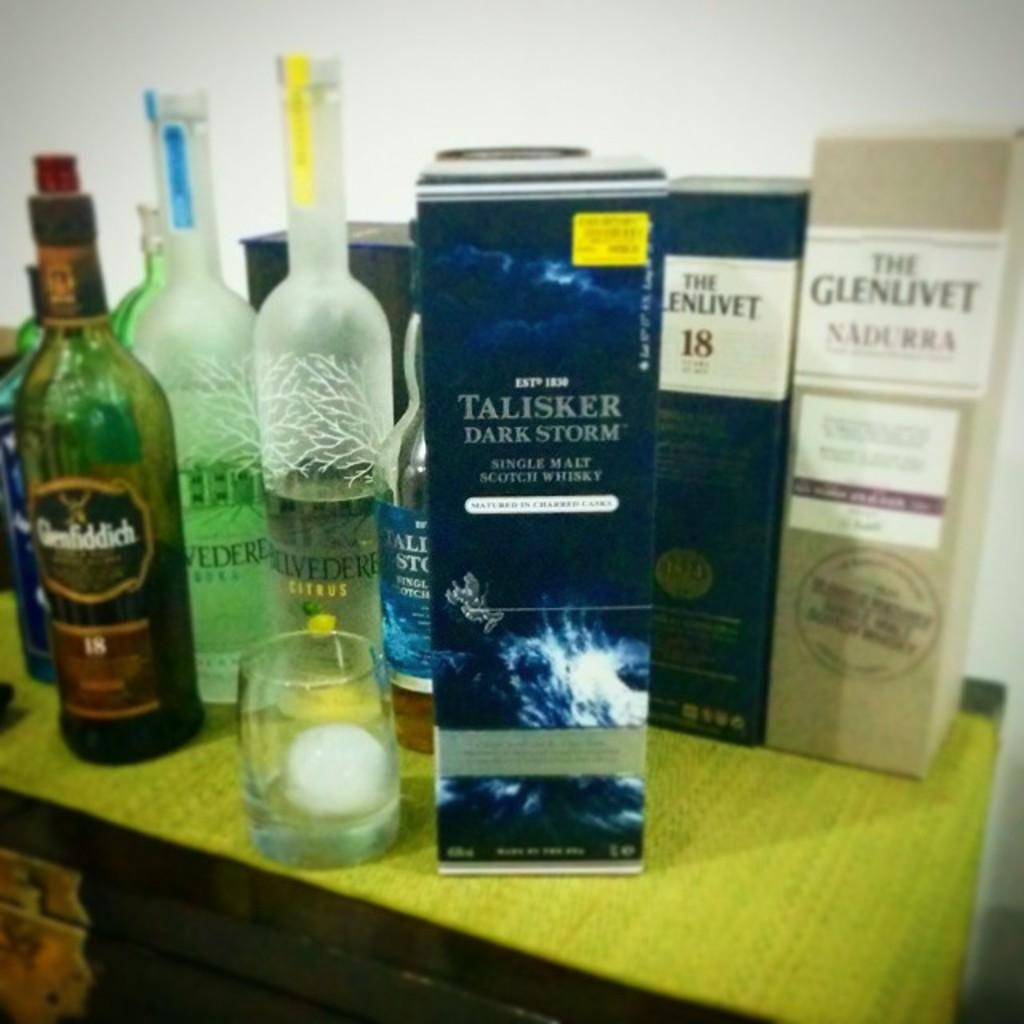What is the fruit on the clear bottle with the yellow sticker?
Ensure brevity in your answer.  Citrus. 